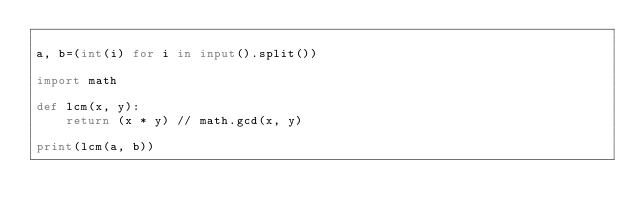Convert code to text. <code><loc_0><loc_0><loc_500><loc_500><_Python_>
a, b=(int(i) for i in input().split())

import math

def lcm(x, y):
    return (x * y) // math.gcd(x, y)

print(lcm(a, b))
</code> 